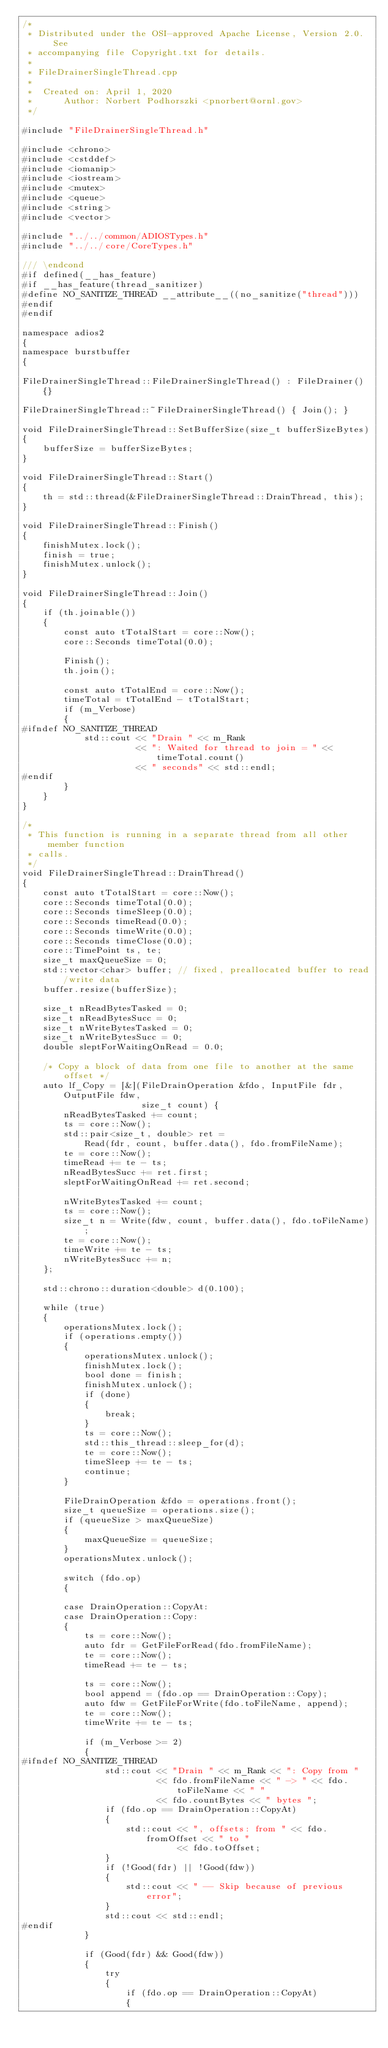<code> <loc_0><loc_0><loc_500><loc_500><_C++_>/*
 * Distributed under the OSI-approved Apache License, Version 2.0.  See
 * accompanying file Copyright.txt for details.
 *
 * FileDrainerSingleThread.cpp
 *
 *  Created on: April 1, 2020
 *      Author: Norbert Podhorszki <pnorbert@ornl.gov>
 */

#include "FileDrainerSingleThread.h"

#include <chrono>
#include <cstddef>
#include <iomanip>
#include <iostream>
#include <mutex>
#include <queue>
#include <string>
#include <vector>

#include "../../common/ADIOSTypes.h"
#include "../../core/CoreTypes.h"

/// \endcond
#if defined(__has_feature)
#if __has_feature(thread_sanitizer)
#define NO_SANITIZE_THREAD __attribute__((no_sanitize("thread")))
#endif
#endif

namespace adios2
{
namespace burstbuffer
{

FileDrainerSingleThread::FileDrainerSingleThread() : FileDrainer() {}

FileDrainerSingleThread::~FileDrainerSingleThread() { Join(); }

void FileDrainerSingleThread::SetBufferSize(size_t bufferSizeBytes)
{
    bufferSize = bufferSizeBytes;
}

void FileDrainerSingleThread::Start()
{
    th = std::thread(&FileDrainerSingleThread::DrainThread, this);
}

void FileDrainerSingleThread::Finish()
{
    finishMutex.lock();
    finish = true;
    finishMutex.unlock();
}

void FileDrainerSingleThread::Join()
{
    if (th.joinable())
    {
        const auto tTotalStart = core::Now();
        core::Seconds timeTotal(0.0);

        Finish();
        th.join();

        const auto tTotalEnd = core::Now();
        timeTotal = tTotalEnd - tTotalStart;
        if (m_Verbose)
        {
#ifndef NO_SANITIZE_THREAD
            std::cout << "Drain " << m_Rank
                      << ": Waited for thread to join = " << timeTotal.count()
                      << " seconds" << std::endl;
#endif
        }
    }
}

/*
 * This function is running in a separate thread from all other member function
 * calls.
 */
void FileDrainerSingleThread::DrainThread()
{
    const auto tTotalStart = core::Now();
    core::Seconds timeTotal(0.0);
    core::Seconds timeSleep(0.0);
    core::Seconds timeRead(0.0);
    core::Seconds timeWrite(0.0);
    core::Seconds timeClose(0.0);
    core::TimePoint ts, te;
    size_t maxQueueSize = 0;
    std::vector<char> buffer; // fixed, preallocated buffer to read/write data
    buffer.resize(bufferSize);

    size_t nReadBytesTasked = 0;
    size_t nReadBytesSucc = 0;
    size_t nWriteBytesTasked = 0;
    size_t nWriteBytesSucc = 0;
    double sleptForWaitingOnRead = 0.0;

    /* Copy a block of data from one file to another at the same offset */
    auto lf_Copy = [&](FileDrainOperation &fdo, InputFile fdr, OutputFile fdw,
                       size_t count) {
        nReadBytesTasked += count;
        ts = core::Now();
        std::pair<size_t, double> ret =
            Read(fdr, count, buffer.data(), fdo.fromFileName);
        te = core::Now();
        timeRead += te - ts;
        nReadBytesSucc += ret.first;
        sleptForWaitingOnRead += ret.second;

        nWriteBytesTasked += count;
        ts = core::Now();
        size_t n = Write(fdw, count, buffer.data(), fdo.toFileName);
        te = core::Now();
        timeWrite += te - ts;
        nWriteBytesSucc += n;
    };

    std::chrono::duration<double> d(0.100);

    while (true)
    {
        operationsMutex.lock();
        if (operations.empty())
        {
            operationsMutex.unlock();
            finishMutex.lock();
            bool done = finish;
            finishMutex.unlock();
            if (done)
            {
                break;
            }
            ts = core::Now();
            std::this_thread::sleep_for(d);
            te = core::Now();
            timeSleep += te - ts;
            continue;
        }

        FileDrainOperation &fdo = operations.front();
        size_t queueSize = operations.size();
        if (queueSize > maxQueueSize)
        {
            maxQueueSize = queueSize;
        }
        operationsMutex.unlock();

        switch (fdo.op)
        {

        case DrainOperation::CopyAt:
        case DrainOperation::Copy:
        {
            ts = core::Now();
            auto fdr = GetFileForRead(fdo.fromFileName);
            te = core::Now();
            timeRead += te - ts;

            ts = core::Now();
            bool append = (fdo.op == DrainOperation::Copy);
            auto fdw = GetFileForWrite(fdo.toFileName, append);
            te = core::Now();
            timeWrite += te - ts;

            if (m_Verbose >= 2)
            {
#ifndef NO_SANITIZE_THREAD
                std::cout << "Drain " << m_Rank << ": Copy from "
                          << fdo.fromFileName << " -> " << fdo.toFileName << " "
                          << fdo.countBytes << " bytes ";
                if (fdo.op == DrainOperation::CopyAt)
                {
                    std::cout << ", offsets: from " << fdo.fromOffset << " to "
                              << fdo.toOffset;
                }
                if (!Good(fdr) || !Good(fdw))
                {
                    std::cout << " -- Skip because of previous error";
                }
                std::cout << std::endl;
#endif
            }

            if (Good(fdr) && Good(fdw))
            {
                try
                {
                    if (fdo.op == DrainOperation::CopyAt)
                    {</code> 